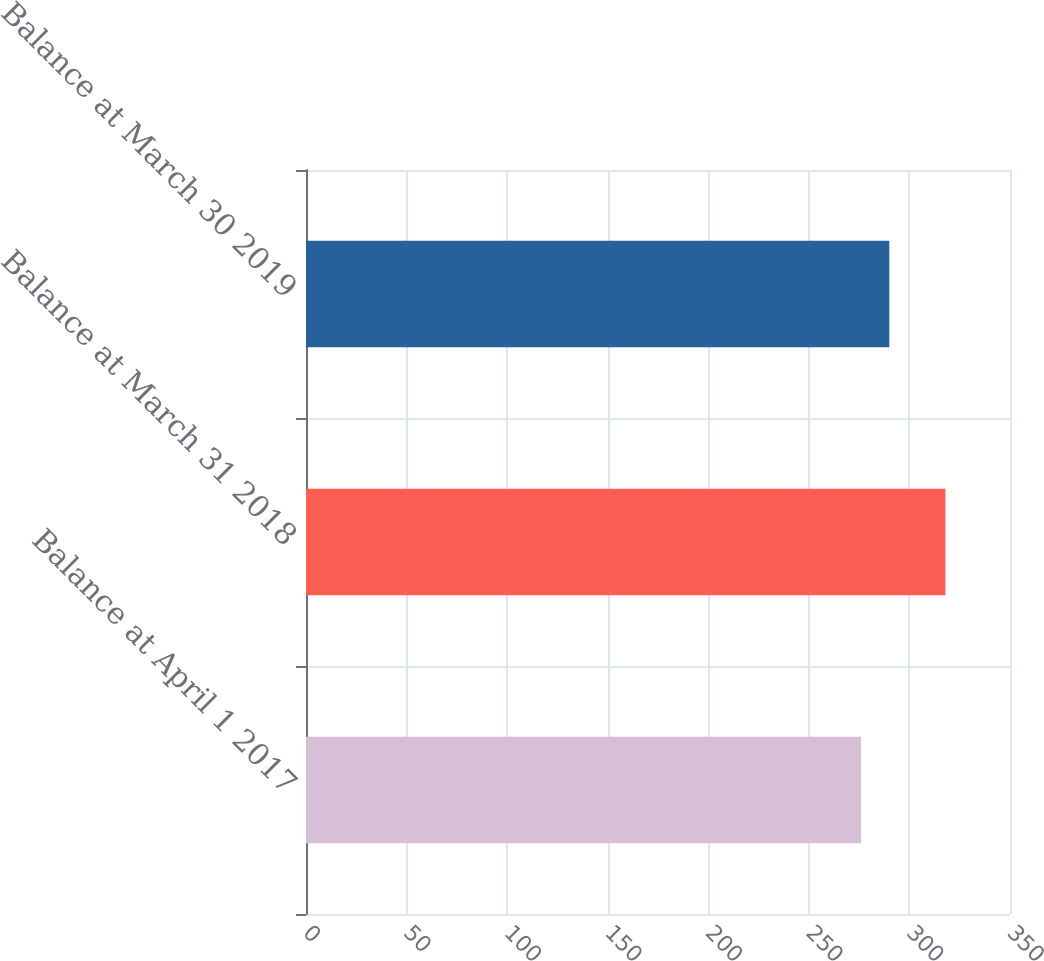Convert chart. <chart><loc_0><loc_0><loc_500><loc_500><bar_chart><fcel>Balance at April 1 2017<fcel>Balance at March 31 2018<fcel>Balance at March 30 2019<nl><fcel>275.9<fcel>317.9<fcel>290<nl></chart> 